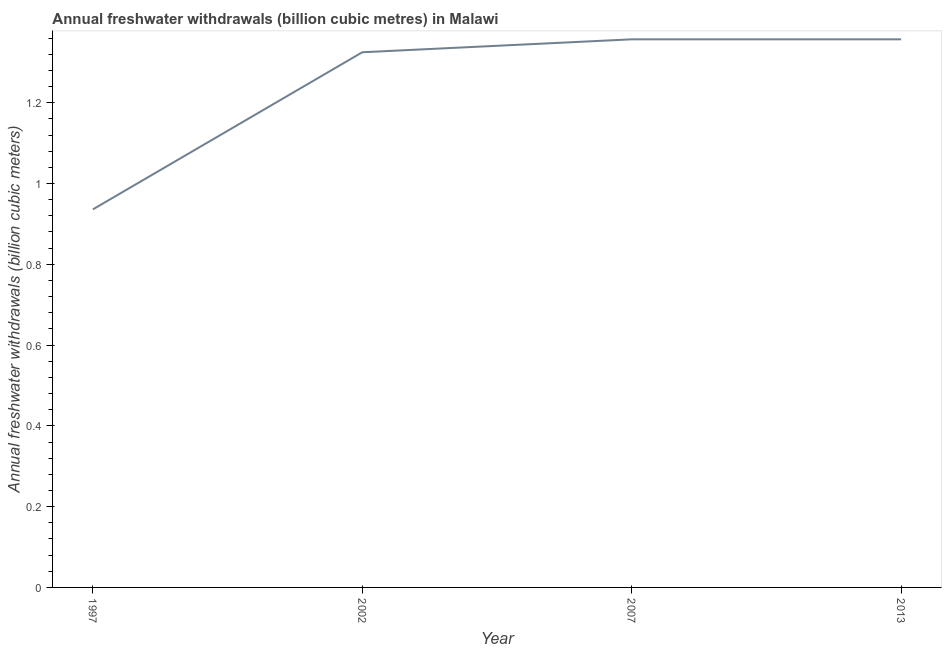What is the annual freshwater withdrawals in 2013?
Make the answer very short. 1.36. Across all years, what is the maximum annual freshwater withdrawals?
Your response must be concise. 1.36. Across all years, what is the minimum annual freshwater withdrawals?
Offer a very short reply. 0.94. In which year was the annual freshwater withdrawals maximum?
Your response must be concise. 2007. What is the sum of the annual freshwater withdrawals?
Ensure brevity in your answer.  4.98. What is the difference between the annual freshwater withdrawals in 2002 and 2013?
Ensure brevity in your answer.  -0.03. What is the average annual freshwater withdrawals per year?
Keep it short and to the point. 1.24. What is the median annual freshwater withdrawals?
Ensure brevity in your answer.  1.34. In how many years, is the annual freshwater withdrawals greater than 0.92 billion cubic meters?
Offer a terse response. 4. Do a majority of the years between 2013 and 2007 (inclusive) have annual freshwater withdrawals greater than 0.4 billion cubic meters?
Your answer should be compact. No. What is the ratio of the annual freshwater withdrawals in 1997 to that in 2007?
Your answer should be compact. 0.69. Is the annual freshwater withdrawals in 1997 less than that in 2002?
Provide a succinct answer. Yes. Is the difference between the annual freshwater withdrawals in 2002 and 2007 greater than the difference between any two years?
Keep it short and to the point. No. What is the difference between the highest and the second highest annual freshwater withdrawals?
Give a very brief answer. 0. Is the sum of the annual freshwater withdrawals in 2007 and 2013 greater than the maximum annual freshwater withdrawals across all years?
Make the answer very short. Yes. What is the difference between the highest and the lowest annual freshwater withdrawals?
Offer a very short reply. 0.42. Does the annual freshwater withdrawals monotonically increase over the years?
Make the answer very short. No. How many lines are there?
Your response must be concise. 1. What is the difference between two consecutive major ticks on the Y-axis?
Ensure brevity in your answer.  0.2. Does the graph contain any zero values?
Provide a short and direct response. No. Does the graph contain grids?
Give a very brief answer. No. What is the title of the graph?
Provide a short and direct response. Annual freshwater withdrawals (billion cubic metres) in Malawi. What is the label or title of the Y-axis?
Provide a succinct answer. Annual freshwater withdrawals (billion cubic meters). What is the Annual freshwater withdrawals (billion cubic meters) in 1997?
Provide a succinct answer. 0.94. What is the Annual freshwater withdrawals (billion cubic meters) in 2002?
Your response must be concise. 1.32. What is the Annual freshwater withdrawals (billion cubic meters) of 2007?
Your answer should be compact. 1.36. What is the Annual freshwater withdrawals (billion cubic meters) of 2013?
Make the answer very short. 1.36. What is the difference between the Annual freshwater withdrawals (billion cubic meters) in 1997 and 2002?
Your answer should be compact. -0.39. What is the difference between the Annual freshwater withdrawals (billion cubic meters) in 1997 and 2007?
Provide a succinct answer. -0.42. What is the difference between the Annual freshwater withdrawals (billion cubic meters) in 1997 and 2013?
Provide a succinct answer. -0.42. What is the difference between the Annual freshwater withdrawals (billion cubic meters) in 2002 and 2007?
Give a very brief answer. -0.03. What is the difference between the Annual freshwater withdrawals (billion cubic meters) in 2002 and 2013?
Your answer should be very brief. -0.03. What is the ratio of the Annual freshwater withdrawals (billion cubic meters) in 1997 to that in 2002?
Make the answer very short. 0.71. What is the ratio of the Annual freshwater withdrawals (billion cubic meters) in 1997 to that in 2007?
Your response must be concise. 0.69. What is the ratio of the Annual freshwater withdrawals (billion cubic meters) in 1997 to that in 2013?
Your response must be concise. 0.69. 